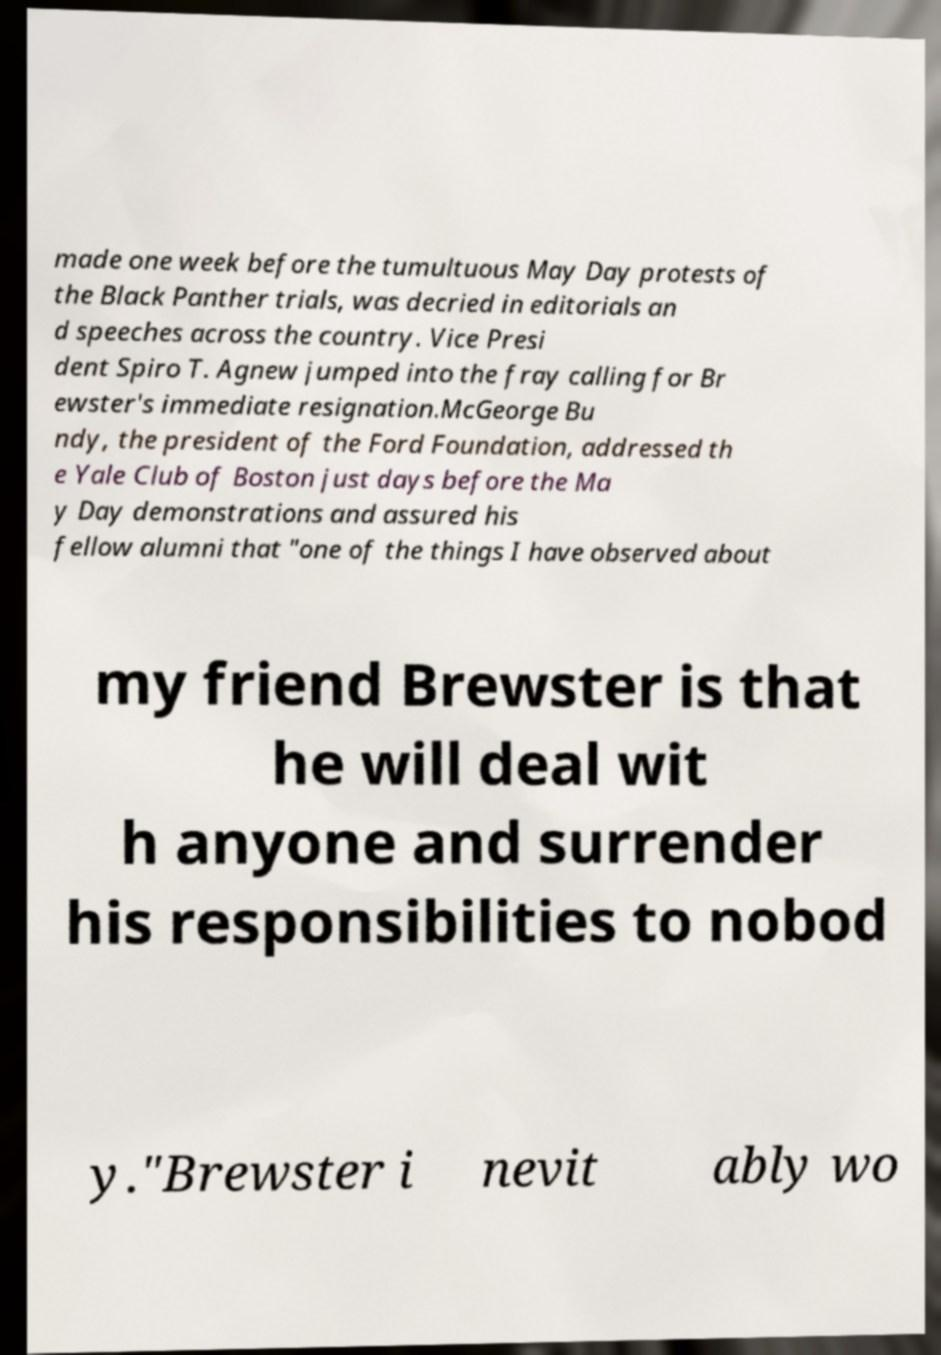Could you assist in decoding the text presented in this image and type it out clearly? made one week before the tumultuous May Day protests of the Black Panther trials, was decried in editorials an d speeches across the country. Vice Presi dent Spiro T. Agnew jumped into the fray calling for Br ewster's immediate resignation.McGeorge Bu ndy, the president of the Ford Foundation, addressed th e Yale Club of Boston just days before the Ma y Day demonstrations and assured his fellow alumni that "one of the things I have observed about my friend Brewster is that he will deal wit h anyone and surrender his responsibilities to nobod y."Brewster i nevit ably wo 